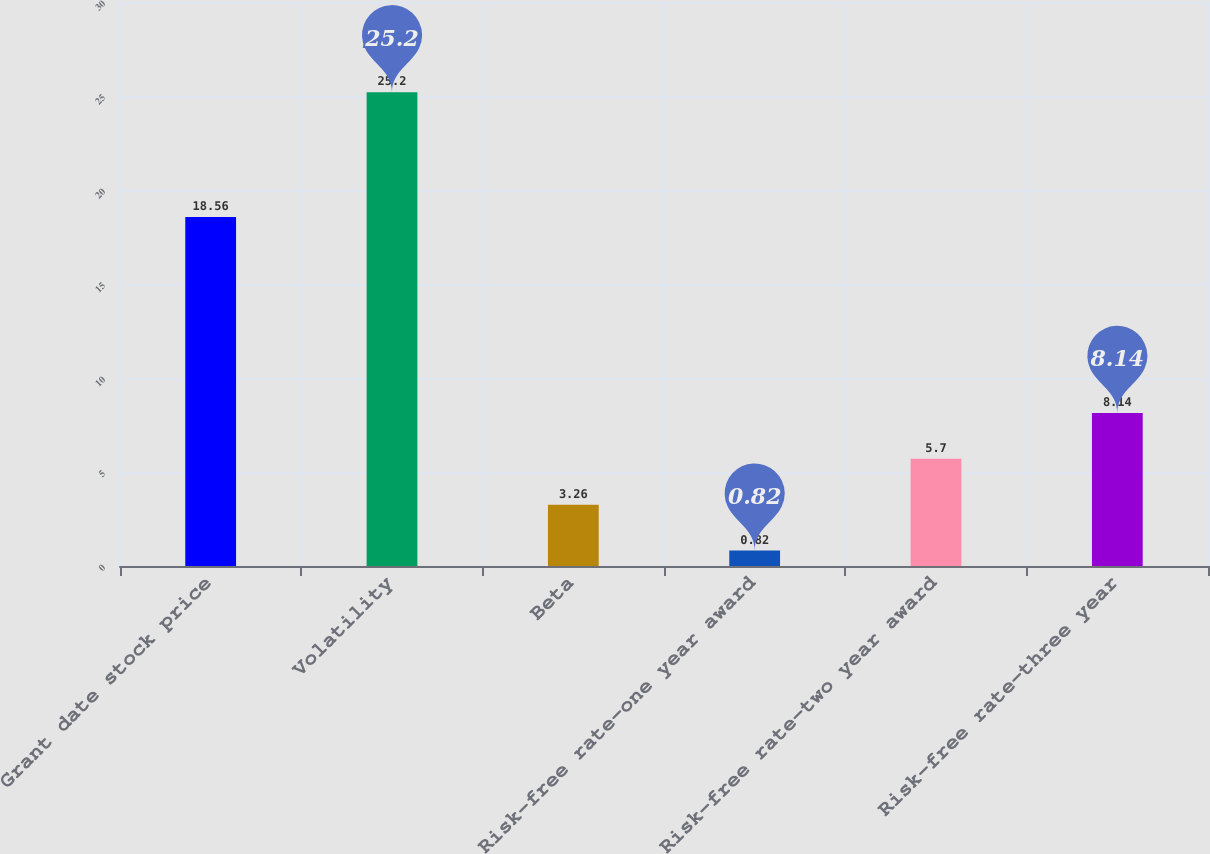<chart> <loc_0><loc_0><loc_500><loc_500><bar_chart><fcel>Grant date stock price<fcel>Volatility<fcel>Beta<fcel>Risk-free rate-one year award<fcel>Risk-free rate-two year award<fcel>Risk-free rate-three year<nl><fcel>18.56<fcel>25.2<fcel>3.26<fcel>0.82<fcel>5.7<fcel>8.14<nl></chart> 